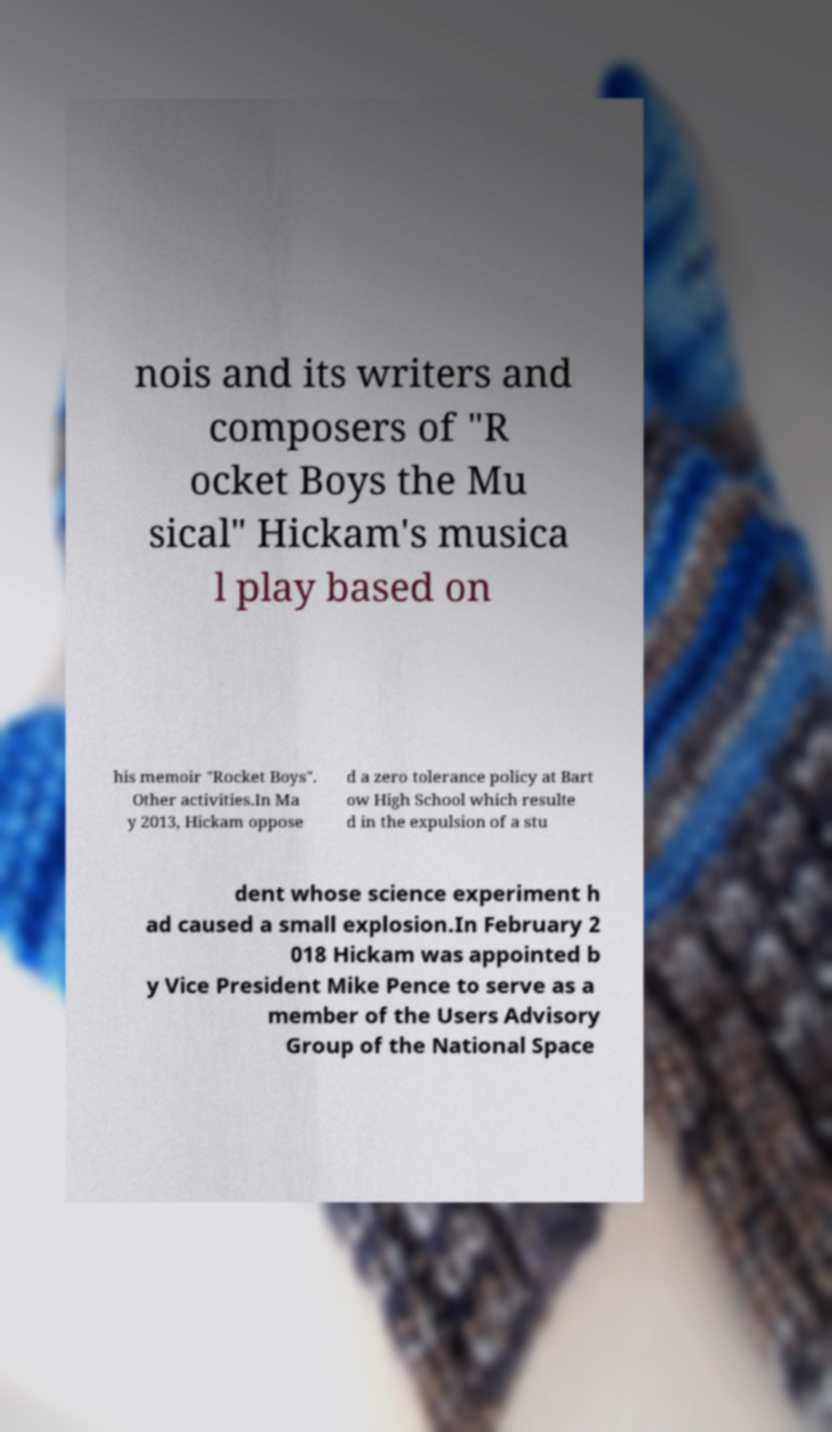Could you assist in decoding the text presented in this image and type it out clearly? nois and its writers and composers of "R ocket Boys the Mu sical" Hickam's musica l play based on his memoir "Rocket Boys". Other activities.In Ma y 2013, Hickam oppose d a zero tolerance policy at Bart ow High School which resulte d in the expulsion of a stu dent whose science experiment h ad caused a small explosion.In February 2 018 Hickam was appointed b y Vice President Mike Pence to serve as a member of the Users Advisory Group of the National Space 